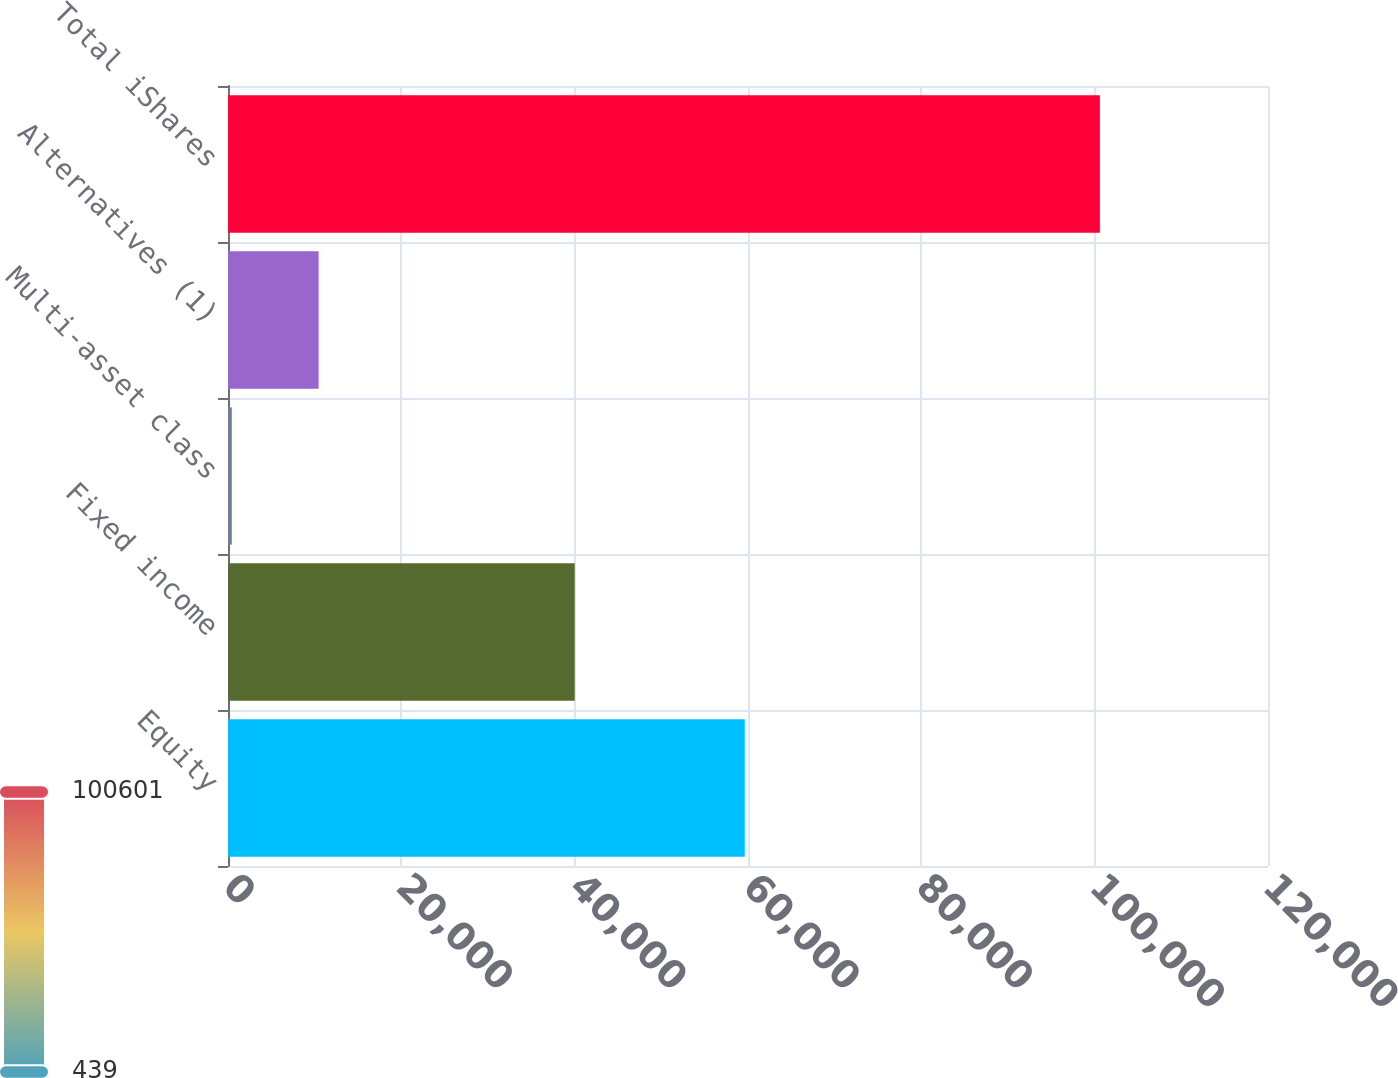Convert chart. <chart><loc_0><loc_0><loc_500><loc_500><bar_chart><fcel>Equity<fcel>Fixed income<fcel>Multi-asset class<fcel>Alternatives (1)<fcel>Total iShares<nl><fcel>59626<fcel>40007<fcel>439<fcel>10455.2<fcel>100601<nl></chart> 